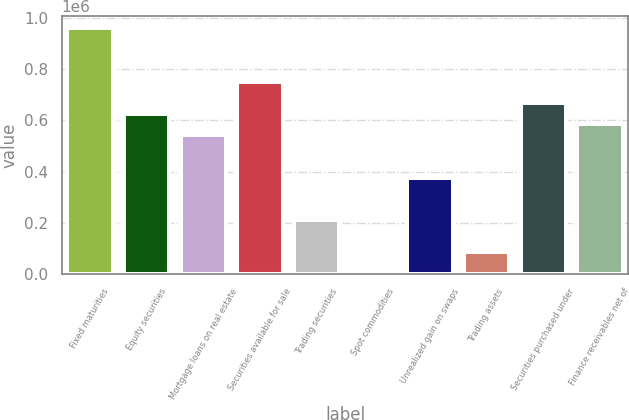Convert chart to OTSL. <chart><loc_0><loc_0><loc_500><loc_500><bar_chart><fcel>Fixed maturities<fcel>Equity securities<fcel>Mortgage loans on real estate<fcel>Securities available for sale<fcel>Trading securities<fcel>Spot commodities<fcel>Unrealized gain on swaps<fcel>Trading assets<fcel>Securities purchased under<fcel>Finance receivables net of<nl><fcel>960804<fcel>626688<fcel>543158<fcel>751981<fcel>209042<fcel>220<fcel>376100<fcel>83749<fcel>668452<fcel>584923<nl></chart> 